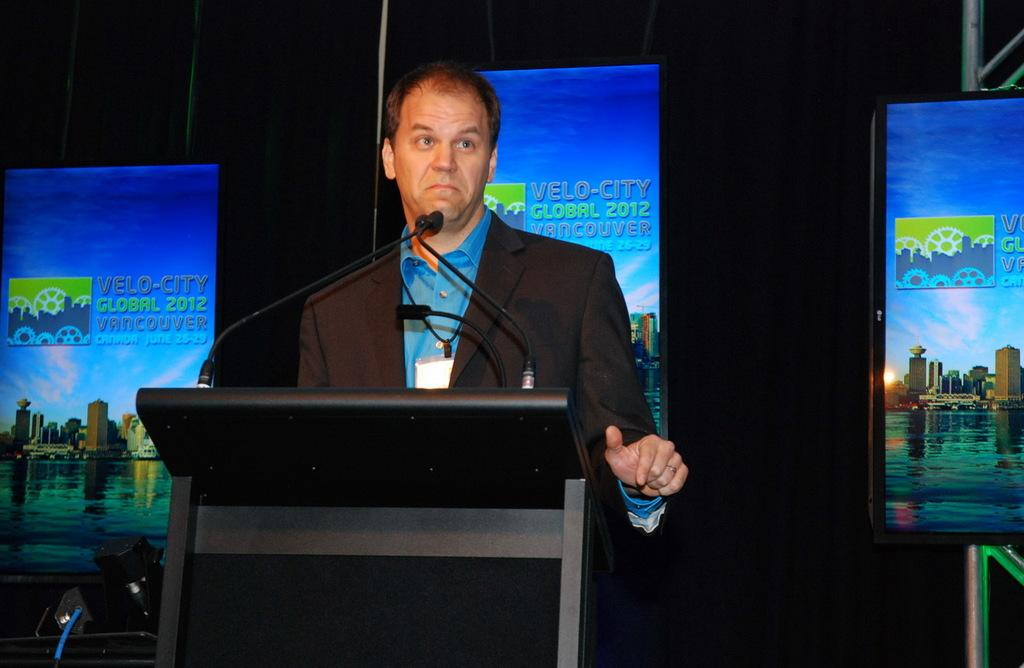<image>
Offer a succinct explanation of the picture presented. man at podium speaking at the velo-city global 2012 in vancouver 